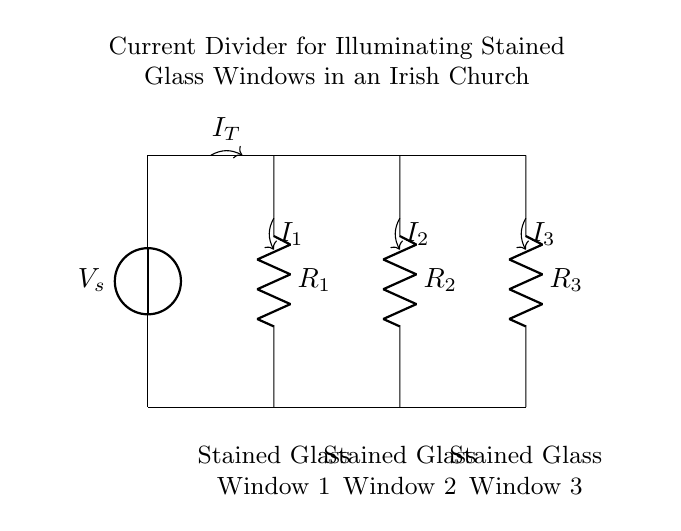What is the total current entering the network? The total current entering the network is labeled as I_T. This is the current supplied by the voltage source, which splits among the three resistors connected to the stained glass windows.
Answer: I_T What type of circuit is used to illuminate the stained glass windows? This circuit is a current divider, which is designed to split the total current into multiple paths, allowing each resistor (representing a window) to receive a specific portion of the current.
Answer: Current divider How many stained glass windows are illuminated in this circuit? There are three stained glass windows connected in parallel, each represented by a resistor. This allows for uniform illumination of the windows when the total current is divided.
Answer: Three What is the role of the resistors in this circuit? The resistors R1, R2, and R3 control the amount of current flowing through each stained glass window. They determine how the total current divides, affecting the illumination level for each window.
Answer: Control current If R1 is 10 ohms, R2 is 20 ohms, and R3 is 30 ohms, which window receives the greatest current? To find the window with the greatest current, we apply the current divider rule, which states that the current through a resistor is inversely proportional to its resistance. R1 is the lowest resistance, suggesting it will receive the most current.
Answer: Stained Glass Window 1 What happens to the current in the circuit if one resistor is removed? If one resistor (and thus one window) is removed, the total current will redistribute among the remaining resistors, potentially increasing the current in those resistors. This may lead to brighter illumination of the remaining windows.
Answer: Increases current to remaining windows 